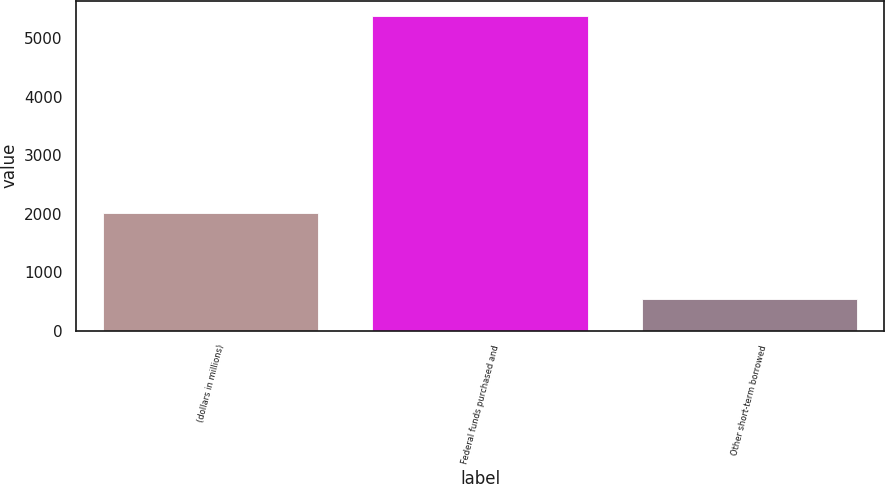Convert chart. <chart><loc_0><loc_0><loc_500><loc_500><bar_chart><fcel>(dollars in millions)<fcel>Federal funds purchased and<fcel>Other short-term borrowed<nl><fcel>2015<fcel>5375<fcel>537.63<nl></chart> 